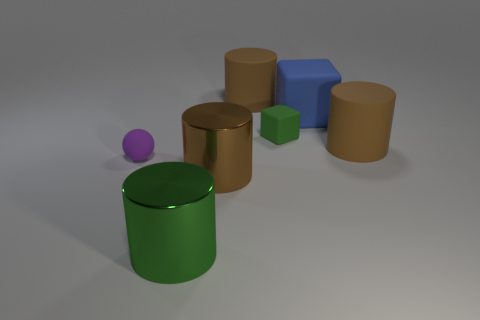There is a brown matte cylinder on the right side of the brown thing that is behind the small thing behind the purple matte thing; what is its size?
Your answer should be compact. Large. What is the size of the metallic thing that is left of the brown metal thing?
Ensure brevity in your answer.  Large. What is the shape of the small thing that is made of the same material as the purple ball?
Provide a short and direct response. Cube. Do the brown thing that is on the right side of the blue object and the tiny green cube have the same material?
Provide a short and direct response. Yes. What number of other things are made of the same material as the green cylinder?
Provide a short and direct response. 1. What number of objects are things that are behind the sphere or small objects on the right side of the big brown metallic object?
Keep it short and to the point. 4. Do the small thing in front of the tiny block and the large metallic object that is left of the brown shiny thing have the same shape?
Provide a succinct answer. No. There is a metal object that is the same size as the green cylinder; what is its shape?
Provide a short and direct response. Cylinder. How many rubber objects are big things or large cylinders?
Give a very brief answer. 3. Does the large object behind the large rubber cube have the same material as the green object behind the small purple matte ball?
Make the answer very short. Yes. 